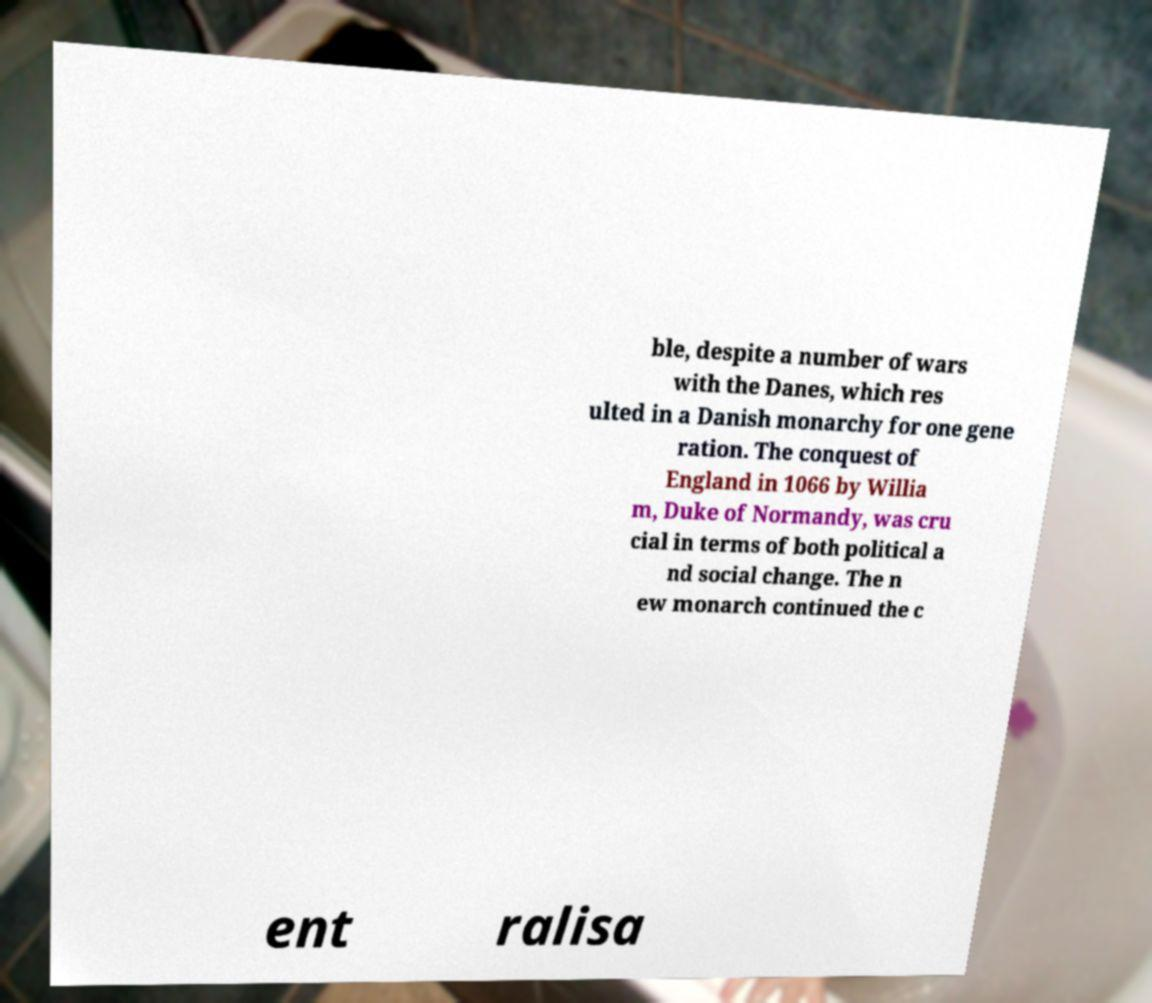Could you assist in decoding the text presented in this image and type it out clearly? ble, despite a number of wars with the Danes, which res ulted in a Danish monarchy for one gene ration. The conquest of England in 1066 by Willia m, Duke of Normandy, was cru cial in terms of both political a nd social change. The n ew monarch continued the c ent ralisa 